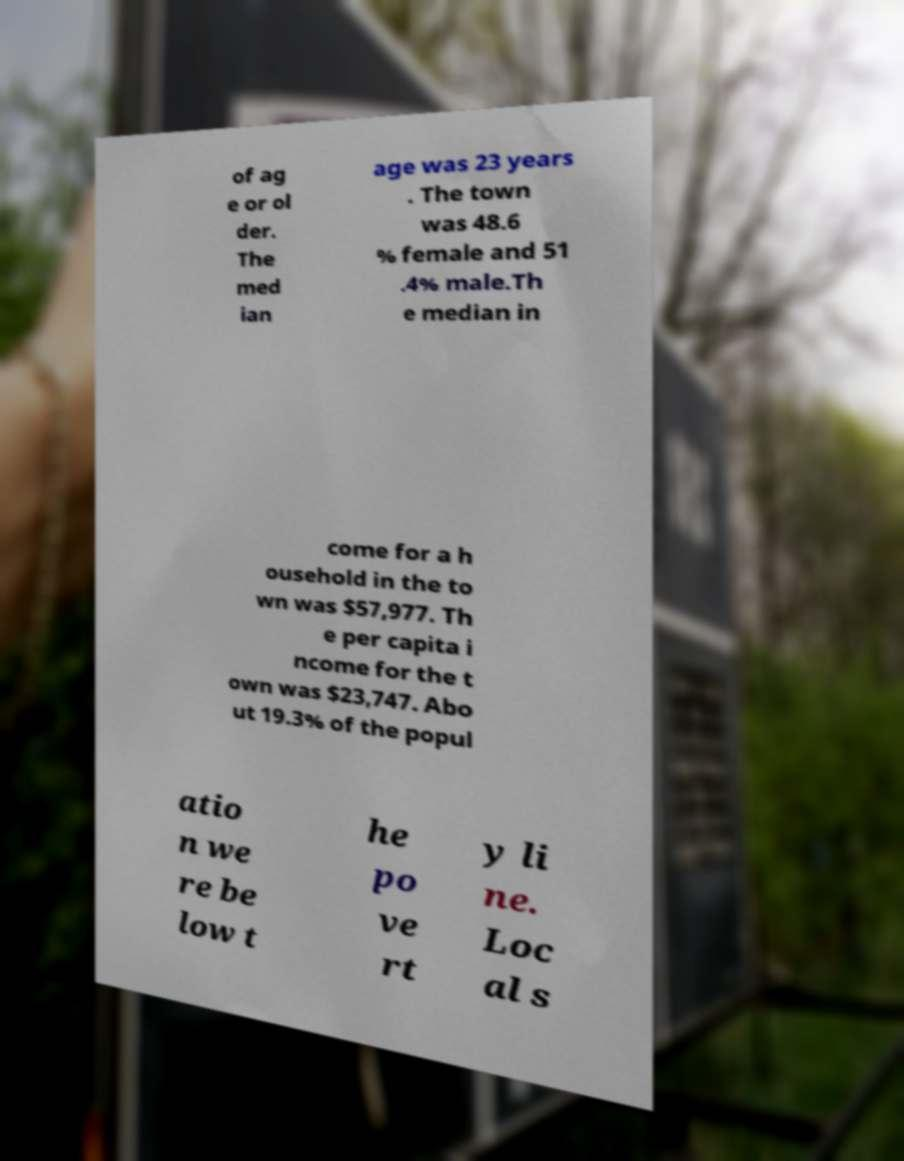Could you assist in decoding the text presented in this image and type it out clearly? of ag e or ol der. The med ian age was 23 years . The town was 48.6 % female and 51 .4% male.Th e median in come for a h ousehold in the to wn was $57,977. Th e per capita i ncome for the t own was $23,747. Abo ut 19.3% of the popul atio n we re be low t he po ve rt y li ne. Loc al s 